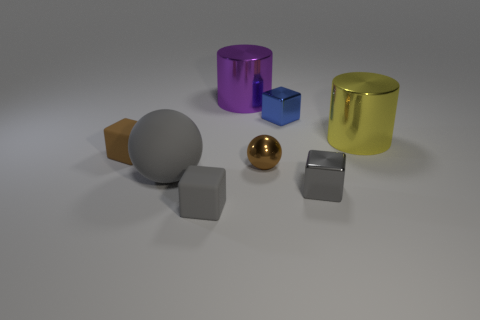Which object in the image seems to reflect the most light? The small golden sphere appears to reflect the most light, giving it a bright, shiny surface that stands out among the objects. 